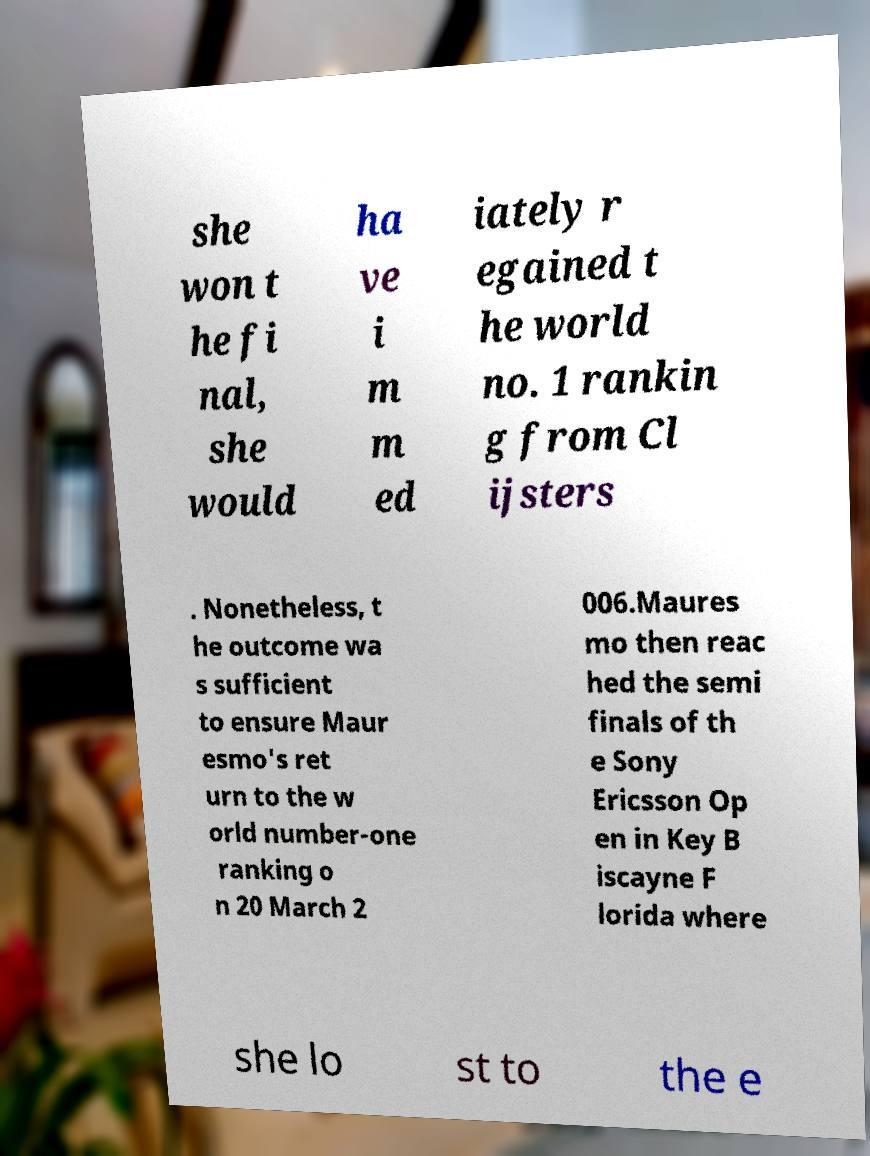Could you assist in decoding the text presented in this image and type it out clearly? she won t he fi nal, she would ha ve i m m ed iately r egained t he world no. 1 rankin g from Cl ijsters . Nonetheless, t he outcome wa s sufficient to ensure Maur esmo's ret urn to the w orld number-one ranking o n 20 March 2 006.Maures mo then reac hed the semi finals of th e Sony Ericsson Op en in Key B iscayne F lorida where she lo st to the e 